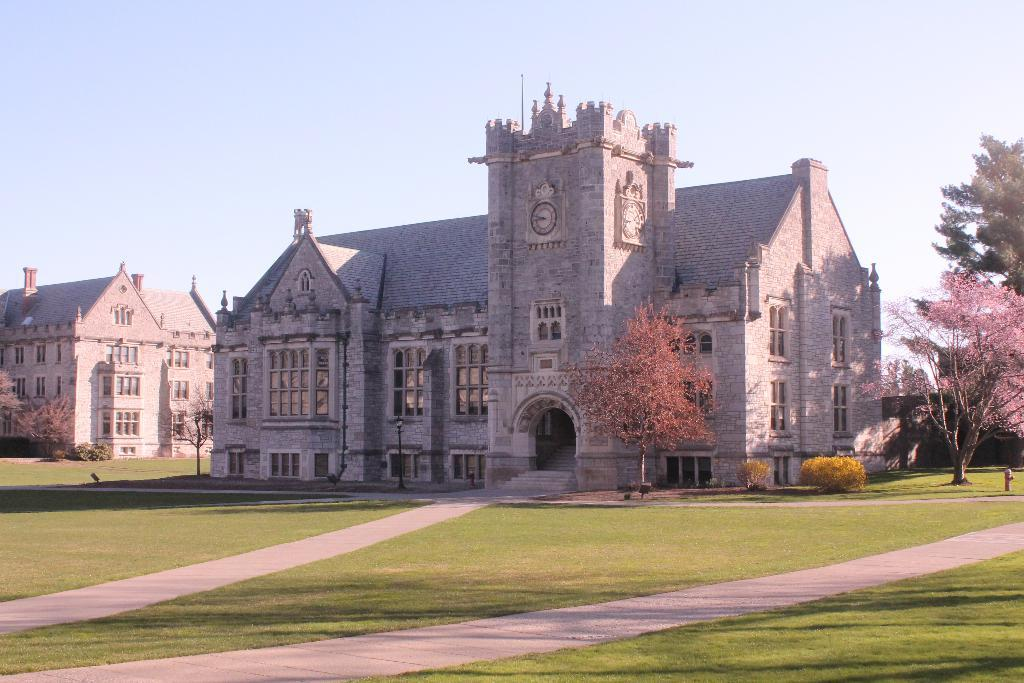What type of structures can be seen in the image? There are buildings with windows in the image. What type of vegetation is present in the image? There are trees and grass in the image. What objects are used for measuring time in the image? There are clocks in the image. What architectural feature is visible in the image? There are steps in the image. What can be seen in the background of the image? The sky is visible in the background of the image. What type of plastic items are being used for the feast in the image? There is no feast or plastic items present in the image. How many pizzas are visible on the grass in the image? There are no pizzas present in the image. 